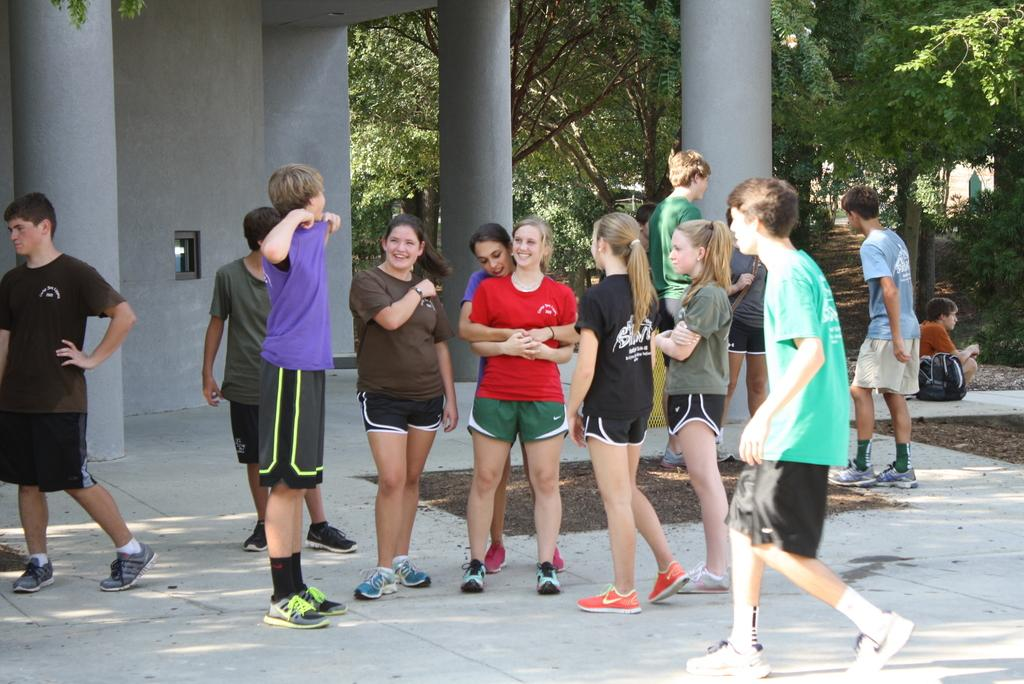How many people are in the image? There is a group of people in the image, but the exact number is not specified. What are the people doing in the image? The people are on the ground, but their specific activity is not mentioned. What can be seen in the background of the image? There are pillars, a wall, and trees in the background of the image. What type of pest is crawling on the self in the image? There is no self or pest present in the image. 